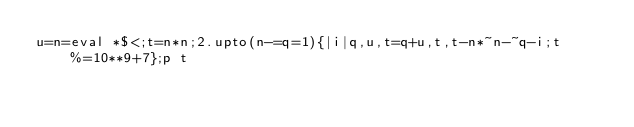Convert code to text. <code><loc_0><loc_0><loc_500><loc_500><_Ruby_>u=n=eval *$<;t=n*n;2.upto(n-=q=1){|i|q,u,t=q+u,t,t-n*~n-~q-i;t%=10**9+7};p t</code> 